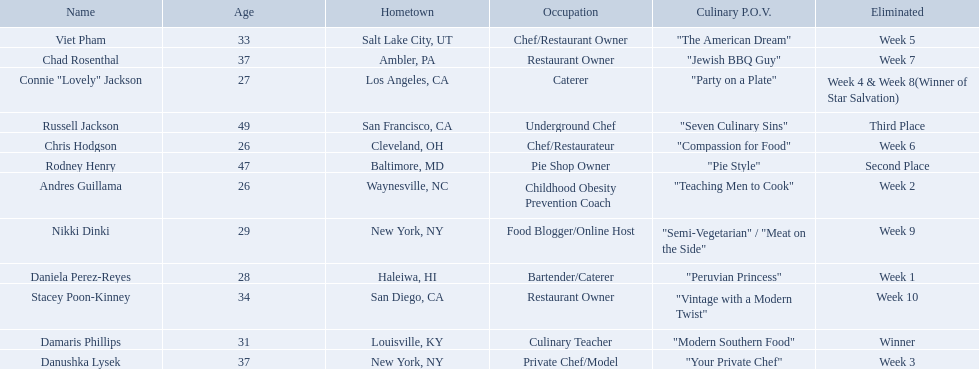Which food network star contestants are in their 20s? Nikki Dinki, Chris Hodgson, Connie "Lovely" Jackson, Andres Guillama, Daniela Perez-Reyes. Parse the full table in json format. {'header': ['Name', 'Age', 'Hometown', 'Occupation', 'Culinary P.O.V.', 'Eliminated'], 'rows': [['Viet Pham', '33', 'Salt Lake City, UT', 'Chef/Restaurant Owner', '"The American Dream"', 'Week 5'], ['Chad Rosenthal', '37', 'Ambler, PA', 'Restaurant Owner', '"Jewish BBQ Guy"', 'Week 7'], ['Connie "Lovely" Jackson', '27', 'Los Angeles, CA', 'Caterer', '"Party on a Plate"', 'Week 4 & Week 8(Winner of Star Salvation)'], ['Russell Jackson', '49', 'San Francisco, CA', 'Underground Chef', '"Seven Culinary Sins"', 'Third Place'], ['Chris Hodgson', '26', 'Cleveland, OH', 'Chef/Restaurateur', '"Compassion for Food"', 'Week 6'], ['Rodney Henry', '47', 'Baltimore, MD', 'Pie Shop Owner', '"Pie Style"', 'Second Place'], ['Andres Guillama', '26', 'Waynesville, NC', 'Childhood Obesity Prevention Coach', '"Teaching Men to Cook"', 'Week 2'], ['Nikki Dinki', '29', 'New York, NY', 'Food Blogger/Online Host', '"Semi-Vegetarian" / "Meat on the Side"', 'Week 9'], ['Daniela Perez-Reyes', '28', 'Haleiwa, HI', 'Bartender/Caterer', '"Peruvian Princess"', 'Week 1'], ['Stacey Poon-Kinney', '34', 'San Diego, CA', 'Restaurant Owner', '"Vintage with a Modern Twist"', 'Week 10'], ['Damaris Phillips', '31', 'Louisville, KY', 'Culinary Teacher', '"Modern Southern Food"', 'Winner'], ['Danushka Lysek', '37', 'New York, NY', 'Private Chef/Model', '"Your Private Chef"', 'Week 3']]} Of these contestants, which one is the same age as chris hodgson? Andres Guillama. Who are the listed food network star contestants? Damaris Phillips, Rodney Henry, Russell Jackson, Stacey Poon-Kinney, Nikki Dinki, Chad Rosenthal, Chris Hodgson, Viet Pham, Connie "Lovely" Jackson, Danushka Lysek, Andres Guillama, Daniela Perez-Reyes. Of those who had the longest p.o.v title? Nikki Dinki. 